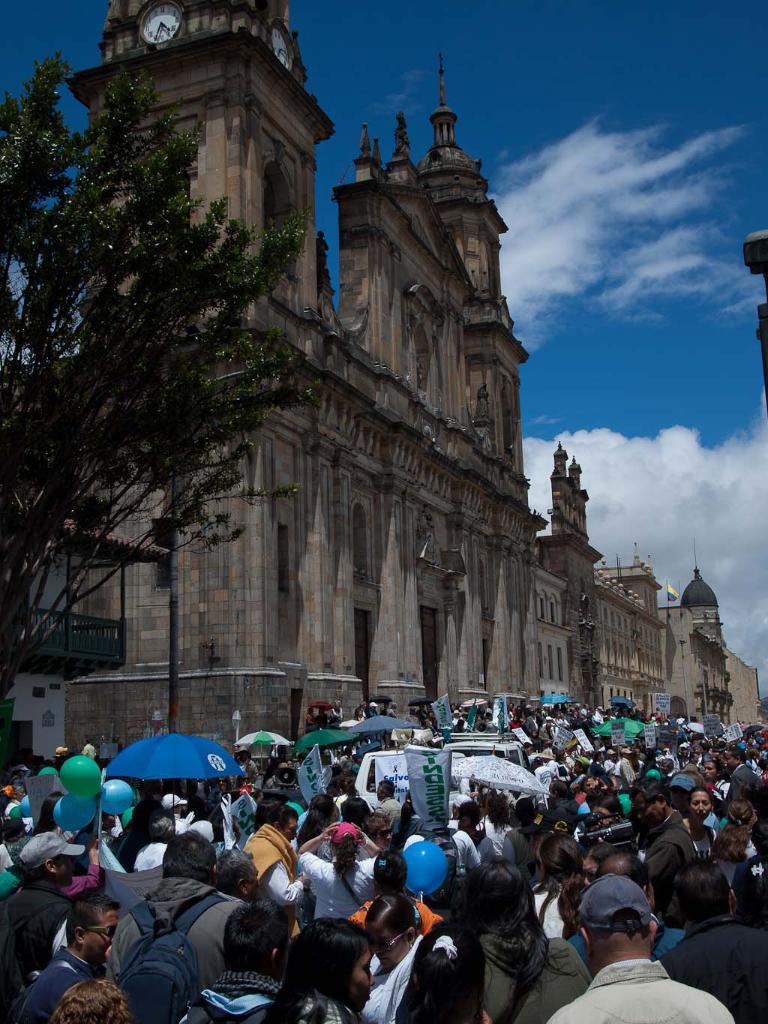Describe this image in one or two sentences. In this picture we can see group of people, few people holding umbrellas and few people holding balloons, in the background we can find few buildings, clouds and a tree, at the top of the image we can see clocks. 